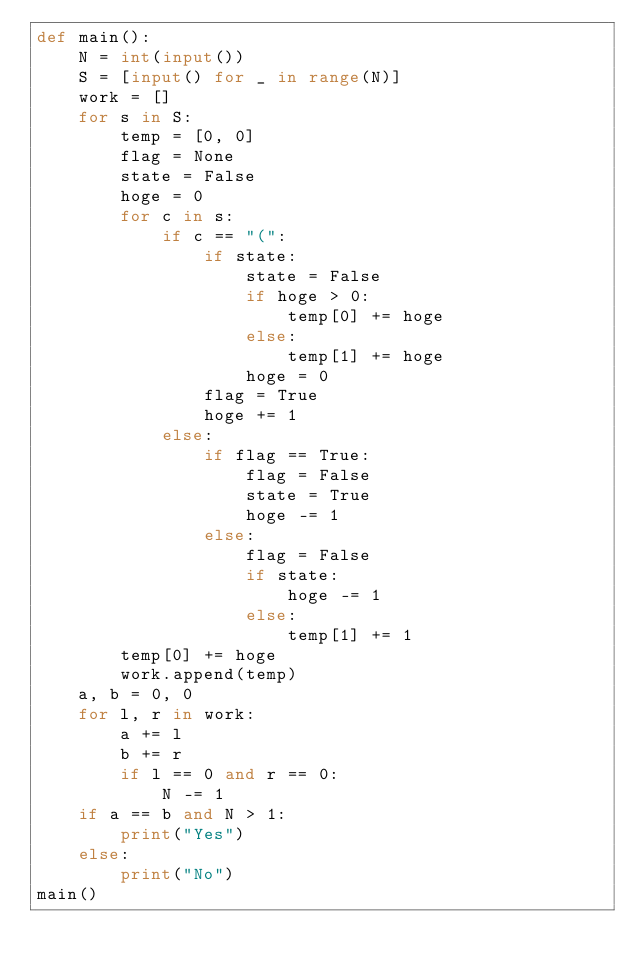<code> <loc_0><loc_0><loc_500><loc_500><_Python_>def main():
    N = int(input())
    S = [input() for _ in range(N)]
    work = []
    for s in S:
        temp = [0, 0]
        flag = None
        state = False
        hoge = 0
        for c in s:
            if c == "(":
                if state:
                    state = False
                    if hoge > 0:
                        temp[0] += hoge
                    else:
                        temp[1] += hoge
                    hoge = 0
                flag = True
                hoge += 1
            else:
                if flag == True:
                    flag = False
                    state = True
                    hoge -= 1
                else:
                    flag = False
                    if state:
                        hoge -= 1
                    else:
                        temp[1] += 1
        temp[0] += hoge
        work.append(temp)
    a, b = 0, 0
    for l, r in work:
        a += l
        b += r
        if l == 0 and r == 0:
            N -= 1
    if a == b and N > 1:
        print("Yes")
    else:
        print("No")
main()</code> 